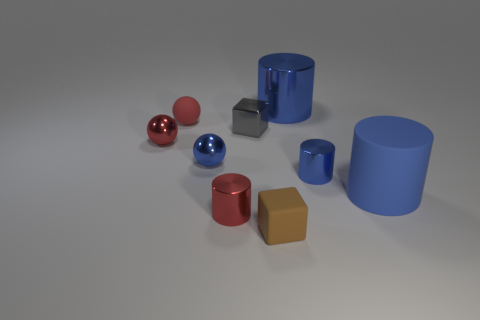Subtract all red balls. How many balls are left? 1 Subtract all blue balls. How many balls are left? 2 Add 1 tiny metal cylinders. How many objects exist? 10 Subtract 2 spheres. How many spheres are left? 1 Subtract all brown cylinders. How many red balls are left? 2 Subtract all cylinders. How many objects are left? 5 Subtract all red matte balls. Subtract all brown rubber things. How many objects are left? 7 Add 9 rubber spheres. How many rubber spheres are left? 10 Add 2 large rubber cylinders. How many large rubber cylinders exist? 3 Subtract 2 blue cylinders. How many objects are left? 7 